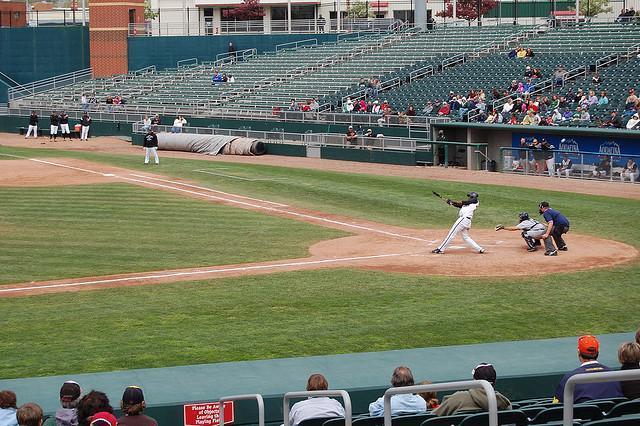How many train cars are orange?
Give a very brief answer. 0. 